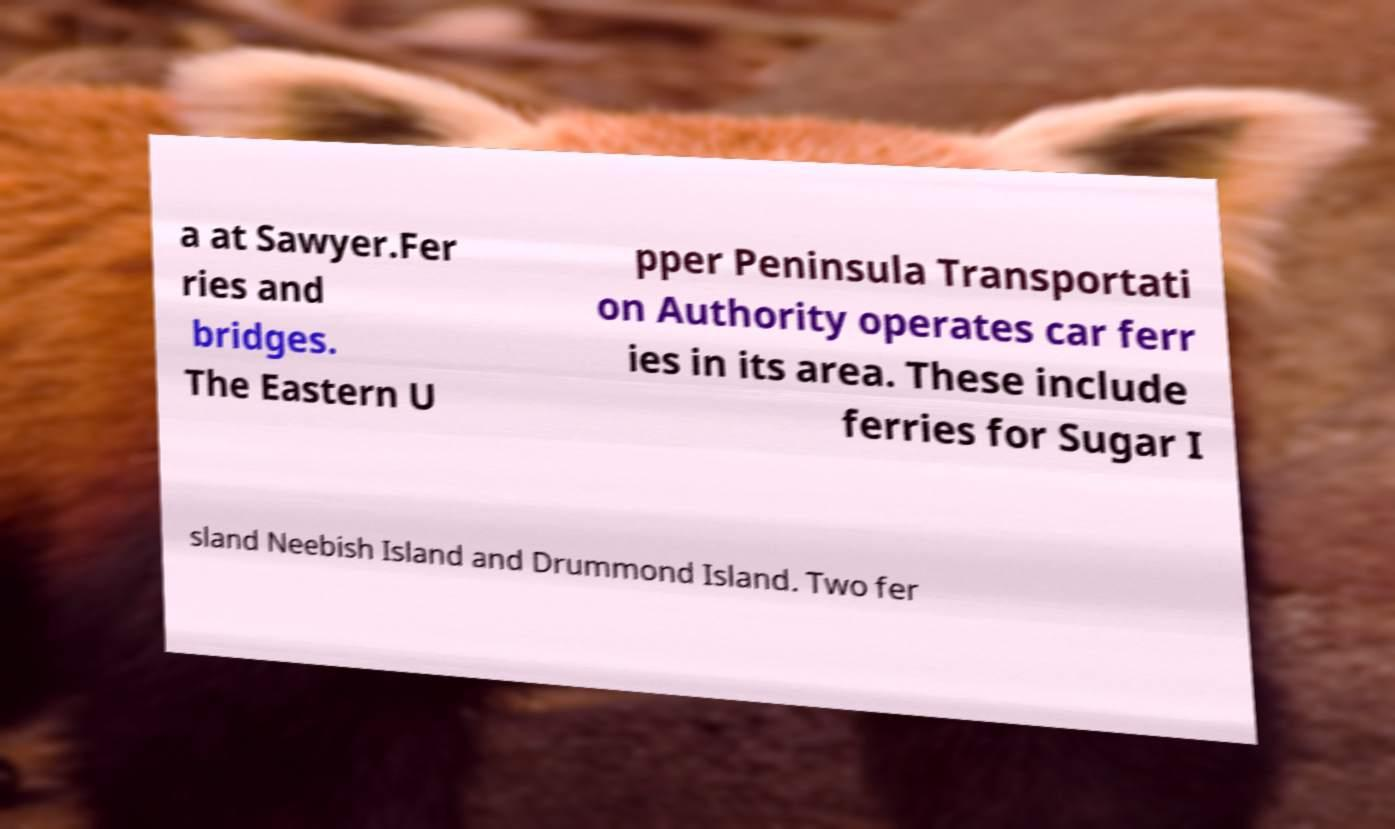Can you read and provide the text displayed in the image?This photo seems to have some interesting text. Can you extract and type it out for me? a at Sawyer.Fer ries and bridges. The Eastern U pper Peninsula Transportati on Authority operates car ferr ies in its area. These include ferries for Sugar I sland Neebish Island and Drummond Island. Two fer 